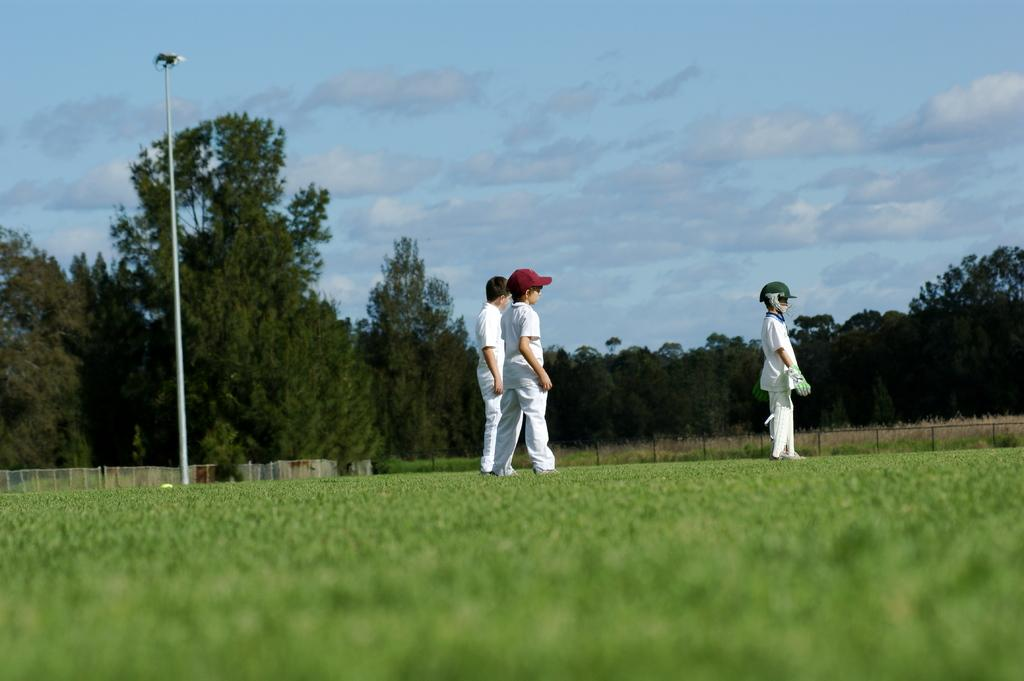How many people are in the image? There are three persons standing in the center of the image. What are the people wearing? The persons are wearing white t-shirts. What can be seen in the background of the image? There is sky, clouds, trees, a fence, and grass visible in the background of the image. What type of office equipment can be seen in the image? There is no office equipment present in the image. What things are the people holding in the image? The provided facts do not mention any objects or things that the people are holding. 